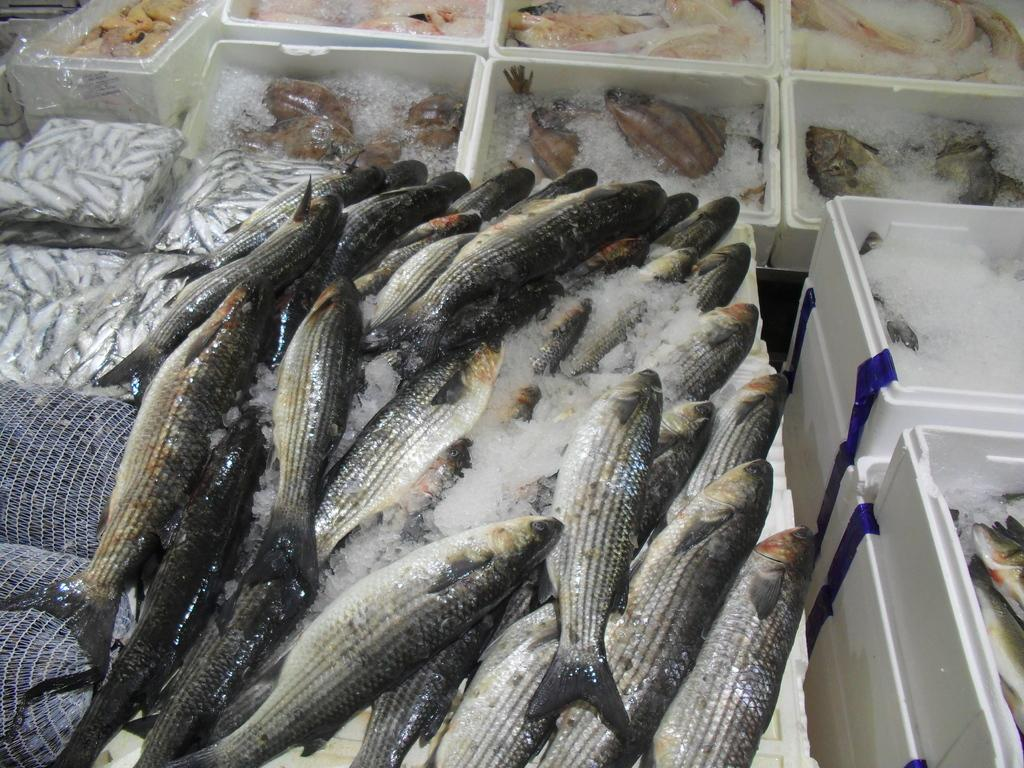What type of animals can be seen in the image? There are fishes in the image. What is present alongside the fishes in the image? There is ice in the image. Can you describe the objects on a platform in the image? The objects on the platform are contained within boxes. How does the sense of smell play a role in the image? The image does not depict any elements that would involve the sense of smell. 